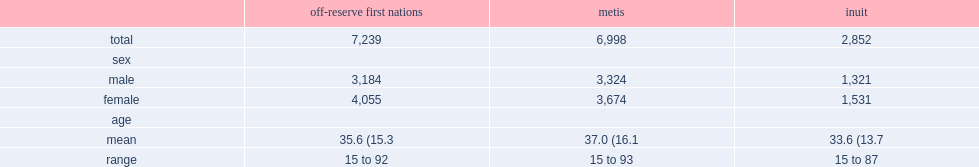How many people in the final study sample comprised 7,239 first nations people living off reserve? 7239.0. How many people in the final study sample comprised metis people living off reserve? 6998.0. How many people in the final study sample comprised inuit people living off reserve? 2852.0. 